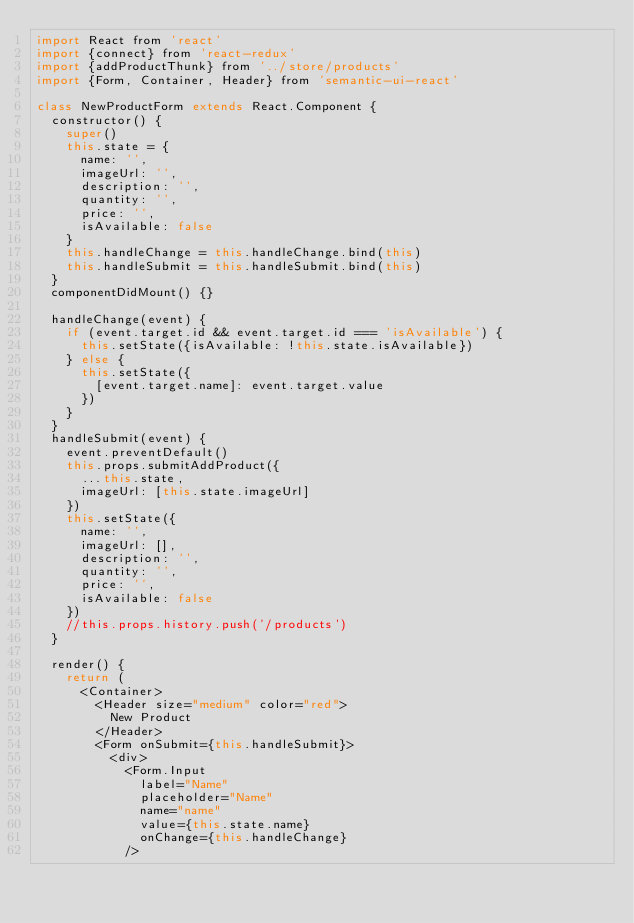Convert code to text. <code><loc_0><loc_0><loc_500><loc_500><_JavaScript_>import React from 'react'
import {connect} from 'react-redux'
import {addProductThunk} from '../store/products'
import {Form, Container, Header} from 'semantic-ui-react'

class NewProductForm extends React.Component {
  constructor() {
    super()
    this.state = {
      name: '',
      imageUrl: '',
      description: '',
      quantity: '',
      price: '',
      isAvailable: false
    }
    this.handleChange = this.handleChange.bind(this)
    this.handleSubmit = this.handleSubmit.bind(this)
  }
  componentDidMount() {}

  handleChange(event) {
    if (event.target.id && event.target.id === 'isAvailable') {
      this.setState({isAvailable: !this.state.isAvailable})
    } else {
      this.setState({
        [event.target.name]: event.target.value
      })
    }
  }
  handleSubmit(event) {
    event.preventDefault()
    this.props.submitAddProduct({
      ...this.state,
      imageUrl: [this.state.imageUrl]
    })
    this.setState({
      name: '',
      imageUrl: [],
      description: '',
      quantity: '',
      price: '',
      isAvailable: false
    })
    //this.props.history.push('/products')
  }

  render() {
    return (
      <Container>
        <Header size="medium" color="red">
          New Product
        </Header>
        <Form onSubmit={this.handleSubmit}>
          <div>
            <Form.Input
              label="Name"
              placeholder="Name"
              name="name"
              value={this.state.name}
              onChange={this.handleChange}
            /></code> 